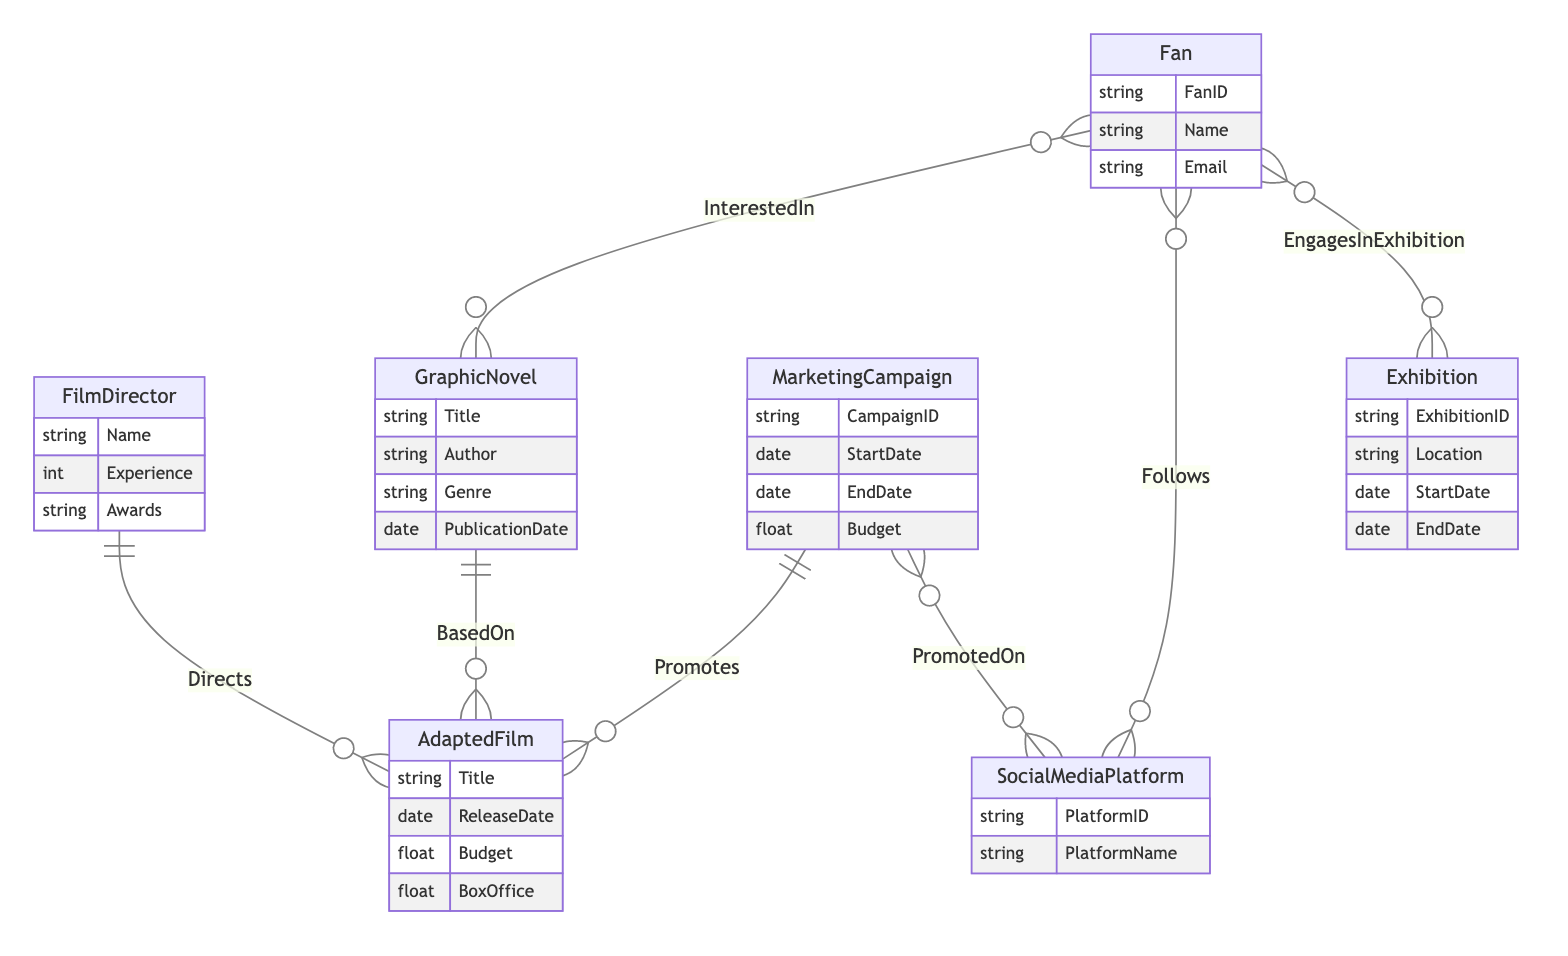What is the main relationship between FilmDirector and AdaptedFilm? The main relationship is "Directs," indicating that a film director is responsible for directing an adapted film. This is shown in the diagram with a direct line linking the two entities with the appropriate label.
Answer: Directs How many attributes does the GraphicNovel entity have? The GraphicNovel entity has four attributes: Title, Author, Genre, and PublicationDate. This can be confirmed by counting the listed attributes under the GraphicNovel entity in the diagram.
Answer: Four What does the relationship "BasedOn" signify? The "BasedOn" relationship signifies that an AdaptedFilm is derived from a GraphicNovel, indicating the source material for the film adaptation. This is evidenced by the connecting line labeled "BasedOn" between the AdaptedFilm and GraphicNovel entities.
Answer: Derived from What is the EngagementType associated with the EngagesInExhibition relationship? The EngagementType is an attribute specific to the EngagesInExhibition relationship between Fan and Exhibition, denoting the nature of the engagement that a fan has with an exhibition. This attribute is indicated specifically next to the relationship in the diagram.
Answer: EngagementType Which entity represents a platform where fans can follow updates? The entity that represents a platform where fans can follow updates is the SocialMediaPlatform. This is clear from the Follows relationship connecting Fan and SocialMediaPlatform in the diagram, emphasizing the fans' interaction on social media.
Answer: SocialMediaPlatform How is MarketingCampaign related to AdaptedFilm? The MarketingCampaign is related to AdaptedFilm through the "Promotes" relationship, indicating that a marketing campaign is responsible for promoting a specific adapted film to the audience, as indicated by the line connecting these two entities.
Answer: Promotes What type of information does the AdaptedFilm entity include regarding financial performance? The AdaptedFilm entity includes information related to financial performance in the attributes Budget and BoxOffice, showing the financial aspects of the film. These attributes are clearly listed in the diagram under the AdaptedFilm entity.
Answer: Budget and BoxOffice What do fans show interest in according to the diagram? Fans show interest in GraphicNovels according to the diagram, as represented by the InterestedIn relationship connecting the Fan and GraphicNovel entities. This denotes that fans engage with the content of graphic novels.
Answer: GraphicNovels 